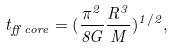<formula> <loc_0><loc_0><loc_500><loc_500>t _ { f f \, c o r e } = ( \frac { \pi ^ { 2 } } { 8 G } \frac { R ^ { 3 } } { M } ) ^ { 1 / 2 } ,</formula> 